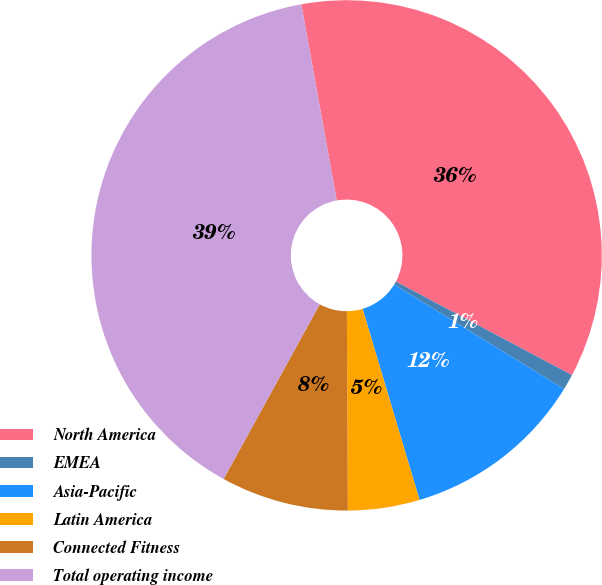<chart> <loc_0><loc_0><loc_500><loc_500><pie_chart><fcel>North America<fcel>EMEA<fcel>Asia-Pacific<fcel>Latin America<fcel>Connected Fitness<fcel>Total operating income<nl><fcel>35.62%<fcel>1.0%<fcel>11.62%<fcel>4.54%<fcel>8.08%<fcel>39.16%<nl></chart> 